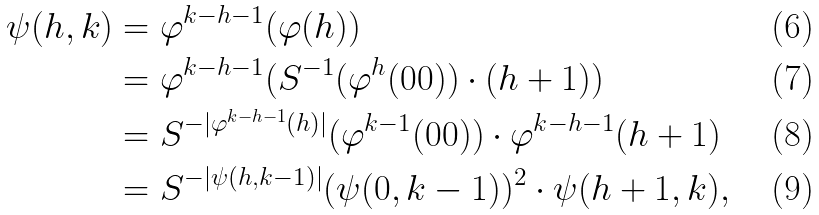Convert formula to latex. <formula><loc_0><loc_0><loc_500><loc_500>\psi ( h , k ) & = \varphi ^ { k - h - 1 } ( \varphi ( h ) ) \\ & = \varphi ^ { k - h - 1 } ( S ^ { - 1 } ( \varphi ^ { h } ( 0 0 ) ) \cdot ( h + 1 ) ) \\ & = S ^ { - | \varphi ^ { k - h - 1 } ( h ) | } ( \varphi ^ { k - 1 } ( 0 0 ) ) \cdot \varphi ^ { k - h - 1 } ( h + 1 ) \\ & = S ^ { - | \psi ( h , k - 1 ) | } ( \psi ( 0 , k - 1 ) ) ^ { 2 } \cdot \psi ( h + 1 , k ) ,</formula> 